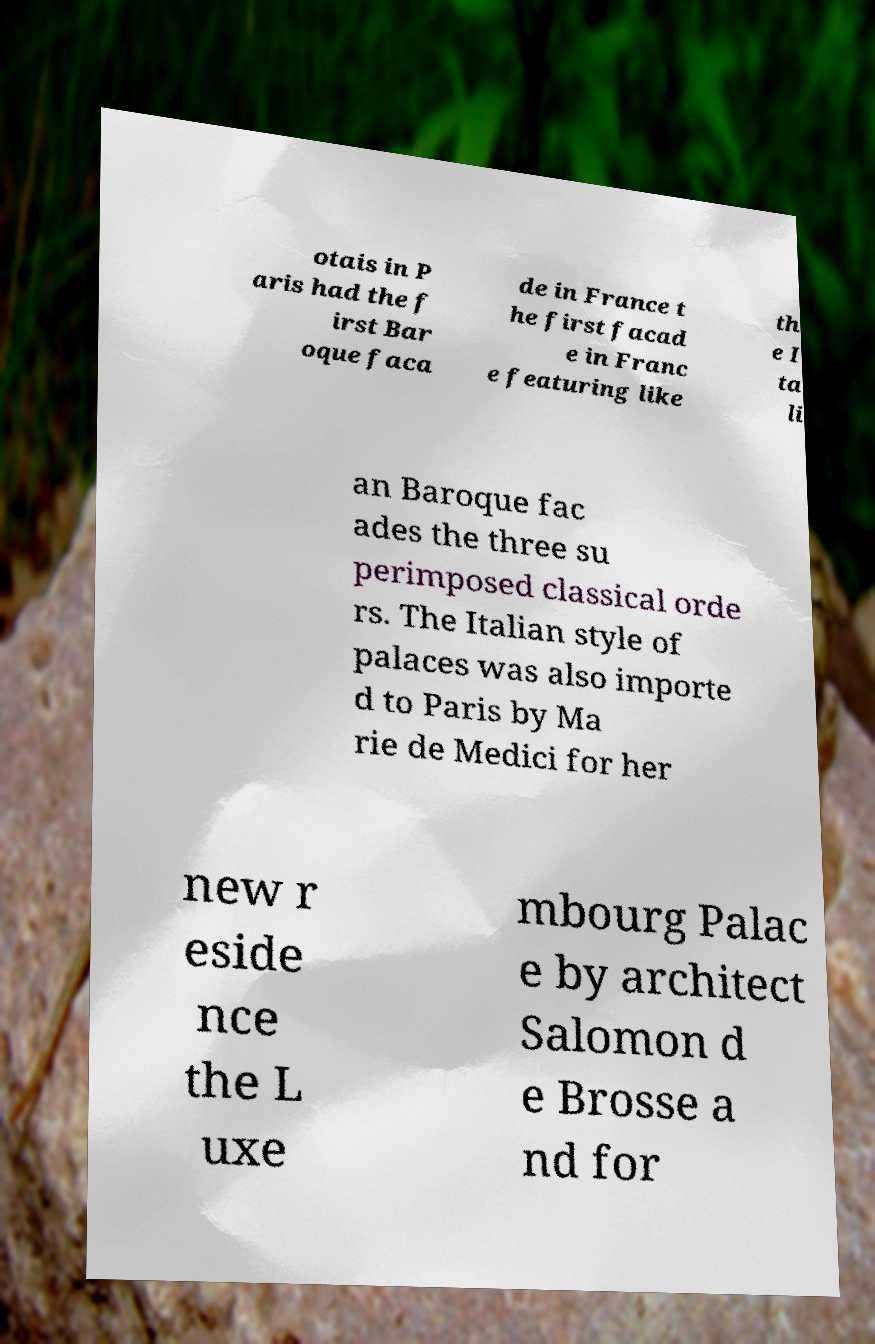Please read and relay the text visible in this image. What does it say? otais in P aris had the f irst Bar oque faca de in France t he first facad e in Franc e featuring like th e I ta li an Baroque fac ades the three su perimposed classical orde rs. The Italian style of palaces was also importe d to Paris by Ma rie de Medici for her new r eside nce the L uxe mbourg Palac e by architect Salomon d e Brosse a nd for 